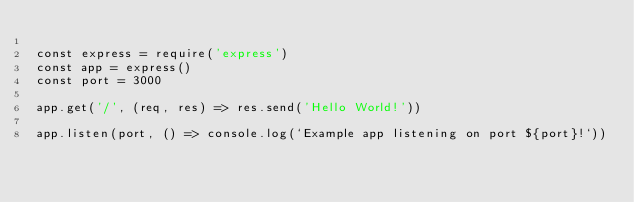<code> <loc_0><loc_0><loc_500><loc_500><_JavaScript_>
const express = require('express')
const app = express()
const port = 3000

app.get('/', (req, res) => res.send('Hello World!'))

app.listen(port, () => console.log(`Example app listening on port ${port}!`))</code> 